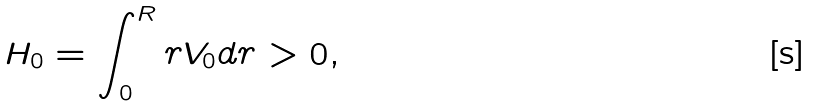<formula> <loc_0><loc_0><loc_500><loc_500>H _ { 0 } = \int _ { 0 } ^ { R } r V _ { 0 } d r > 0 ,</formula> 